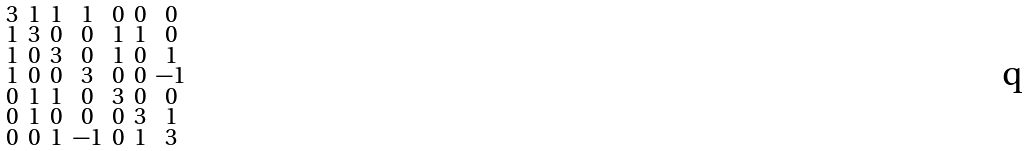Convert formula to latex. <formula><loc_0><loc_0><loc_500><loc_500>\begin{smallmatrix} 3 & 1 & 1 & 1 & 0 & 0 & 0 \\ 1 & 3 & 0 & 0 & 1 & 1 & 0 \\ 1 & 0 & 3 & 0 & 1 & 0 & 1 \\ 1 & 0 & 0 & 3 & 0 & 0 & - 1 \\ 0 & 1 & 1 & 0 & 3 & 0 & 0 \\ 0 & 1 & 0 & 0 & 0 & 3 & 1 \\ 0 & 0 & 1 & - 1 & 0 & 1 & 3 \end{smallmatrix}</formula> 